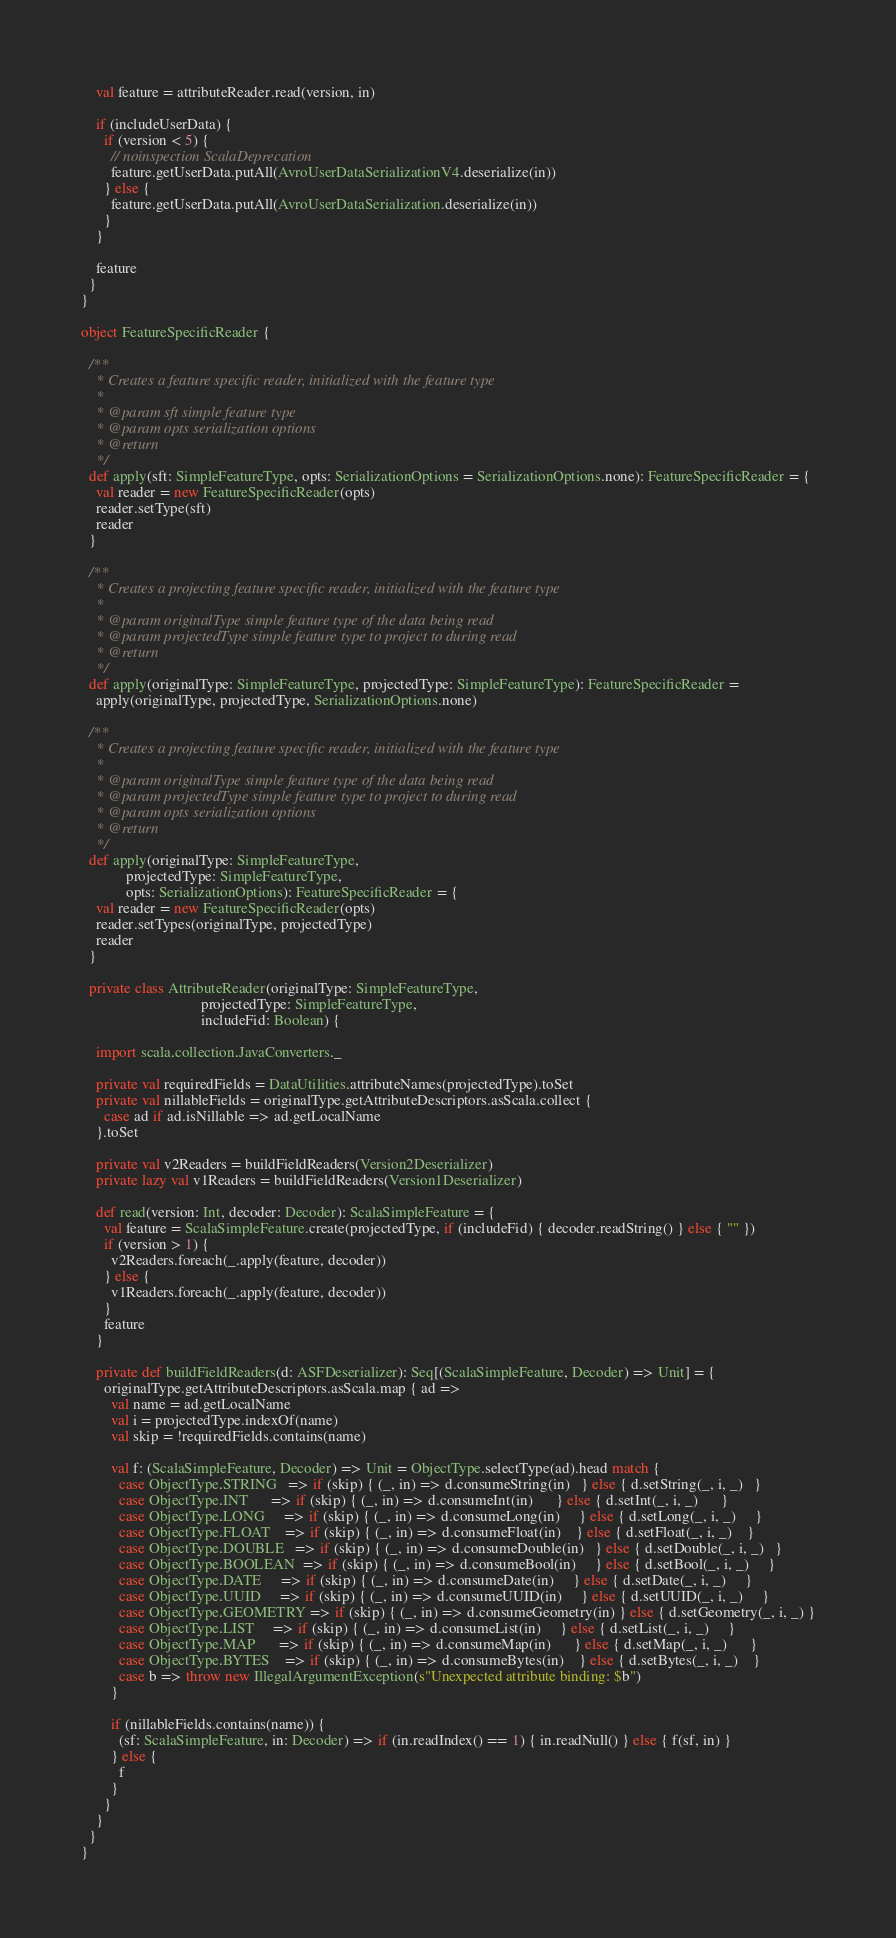<code> <loc_0><loc_0><loc_500><loc_500><_Scala_>
    val feature = attributeReader.read(version, in)

    if (includeUserData) {
      if (version < 5) {
        // noinspection ScalaDeprecation
        feature.getUserData.putAll(AvroUserDataSerializationV4.deserialize(in))
      } else {
        feature.getUserData.putAll(AvroUserDataSerialization.deserialize(in))
      }
    }

    feature
  }
}

object FeatureSpecificReader {

  /**
    * Creates a feature specific reader, initialized with the feature type
    *
    * @param sft simple feature type
    * @param opts serialization options
    * @return
    */
  def apply(sft: SimpleFeatureType, opts: SerializationOptions = SerializationOptions.none): FeatureSpecificReader = {
    val reader = new FeatureSpecificReader(opts)
    reader.setType(sft)
    reader
  }

  /**
    * Creates a projecting feature specific reader, initialized with the feature type
    *
    * @param originalType simple feature type of the data being read
    * @param projectedType simple feature type to project to during read
    * @return
    */
  def apply(originalType: SimpleFeatureType, projectedType: SimpleFeatureType): FeatureSpecificReader =
    apply(originalType, projectedType, SerializationOptions.none)

  /**
    * Creates a projecting feature specific reader, initialized with the feature type
    *
    * @param originalType simple feature type of the data being read
    * @param projectedType simple feature type to project to during read
    * @param opts serialization options
    * @return
    */
  def apply(originalType: SimpleFeatureType,
            projectedType: SimpleFeatureType,
            opts: SerializationOptions): FeatureSpecificReader = {
    val reader = new FeatureSpecificReader(opts)
    reader.setTypes(originalType, projectedType)
    reader
  }

  private class AttributeReader(originalType: SimpleFeatureType,
                                projectedType: SimpleFeatureType,
                                includeFid: Boolean) {

    import scala.collection.JavaConverters._

    private val requiredFields = DataUtilities.attributeNames(projectedType).toSet
    private val nillableFields = originalType.getAttributeDescriptors.asScala.collect {
      case ad if ad.isNillable => ad.getLocalName
    }.toSet

    private val v2Readers = buildFieldReaders(Version2Deserializer)
    private lazy val v1Readers = buildFieldReaders(Version1Deserializer)

    def read(version: Int, decoder: Decoder): ScalaSimpleFeature = {
      val feature = ScalaSimpleFeature.create(projectedType, if (includeFid) { decoder.readString() } else { "" })
      if (version > 1) {
        v2Readers.foreach(_.apply(feature, decoder))
      } else {
        v1Readers.foreach(_.apply(feature, decoder))
      }
      feature
    }

    private def buildFieldReaders(d: ASFDeserializer): Seq[(ScalaSimpleFeature, Decoder) => Unit] = {
      originalType.getAttributeDescriptors.asScala.map { ad =>
        val name = ad.getLocalName
        val i = projectedType.indexOf(name)
        val skip = !requiredFields.contains(name)

        val f: (ScalaSimpleFeature, Decoder) => Unit = ObjectType.selectType(ad).head match {
          case ObjectType.STRING   => if (skip) { (_, in) => d.consumeString(in)   } else { d.setString(_, i, _)   }
          case ObjectType.INT      => if (skip) { (_, in) => d.consumeInt(in)      } else { d.setInt(_, i, _)      }
          case ObjectType.LONG     => if (skip) { (_, in) => d.consumeLong(in)     } else { d.setLong(_, i, _)     }
          case ObjectType.FLOAT    => if (skip) { (_, in) => d.consumeFloat(in)    } else { d.setFloat(_, i, _)    }
          case ObjectType.DOUBLE   => if (skip) { (_, in) => d.consumeDouble(in)   } else { d.setDouble(_, i, _)   }
          case ObjectType.BOOLEAN  => if (skip) { (_, in) => d.consumeBool(in)     } else { d.setBool(_, i, _)     }
          case ObjectType.DATE     => if (skip) { (_, in) => d.consumeDate(in)     } else { d.setDate(_, i, _)     }
          case ObjectType.UUID     => if (skip) { (_, in) => d.consumeUUID(in)     } else { d.setUUID(_, i, _)     }
          case ObjectType.GEOMETRY => if (skip) { (_, in) => d.consumeGeometry(in) } else { d.setGeometry(_, i, _) }
          case ObjectType.LIST     => if (skip) { (_, in) => d.consumeList(in)     } else { d.setList(_, i, _)     }
          case ObjectType.MAP      => if (skip) { (_, in) => d.consumeMap(in)      } else { d.setMap(_, i, _)      }
          case ObjectType.BYTES    => if (skip) { (_, in) => d.consumeBytes(in)    } else { d.setBytes(_, i, _)    }
          case b => throw new IllegalArgumentException(s"Unexpected attribute binding: $b")
        }

        if (nillableFields.contains(name)) {
          (sf: ScalaSimpleFeature, in: Decoder) => if (in.readIndex() == 1) { in.readNull() } else { f(sf, in) }
        } else {
          f
        }
      }
    }
  }
}
</code> 